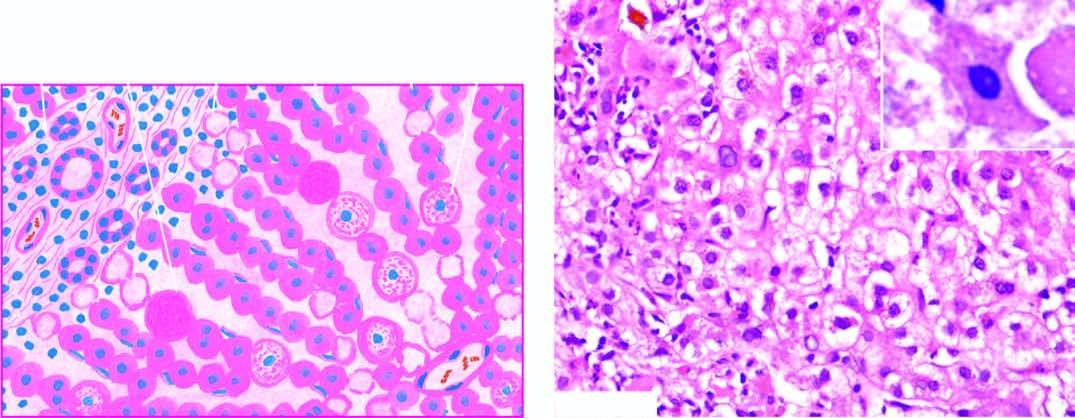what are indicative of more severe liver cell injury?
Answer the question using a single word or phrase. Acidophilic councilman bodies 